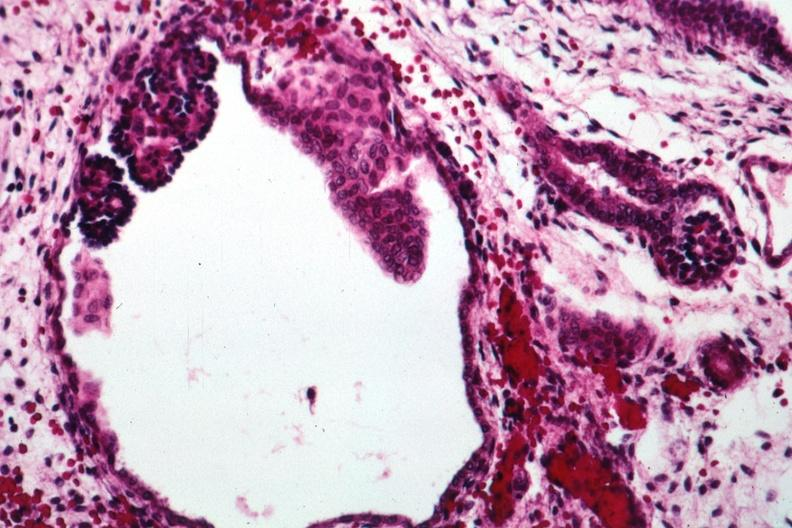what is present?
Answer the question using a single word or phrase. Polycystic disease infant 